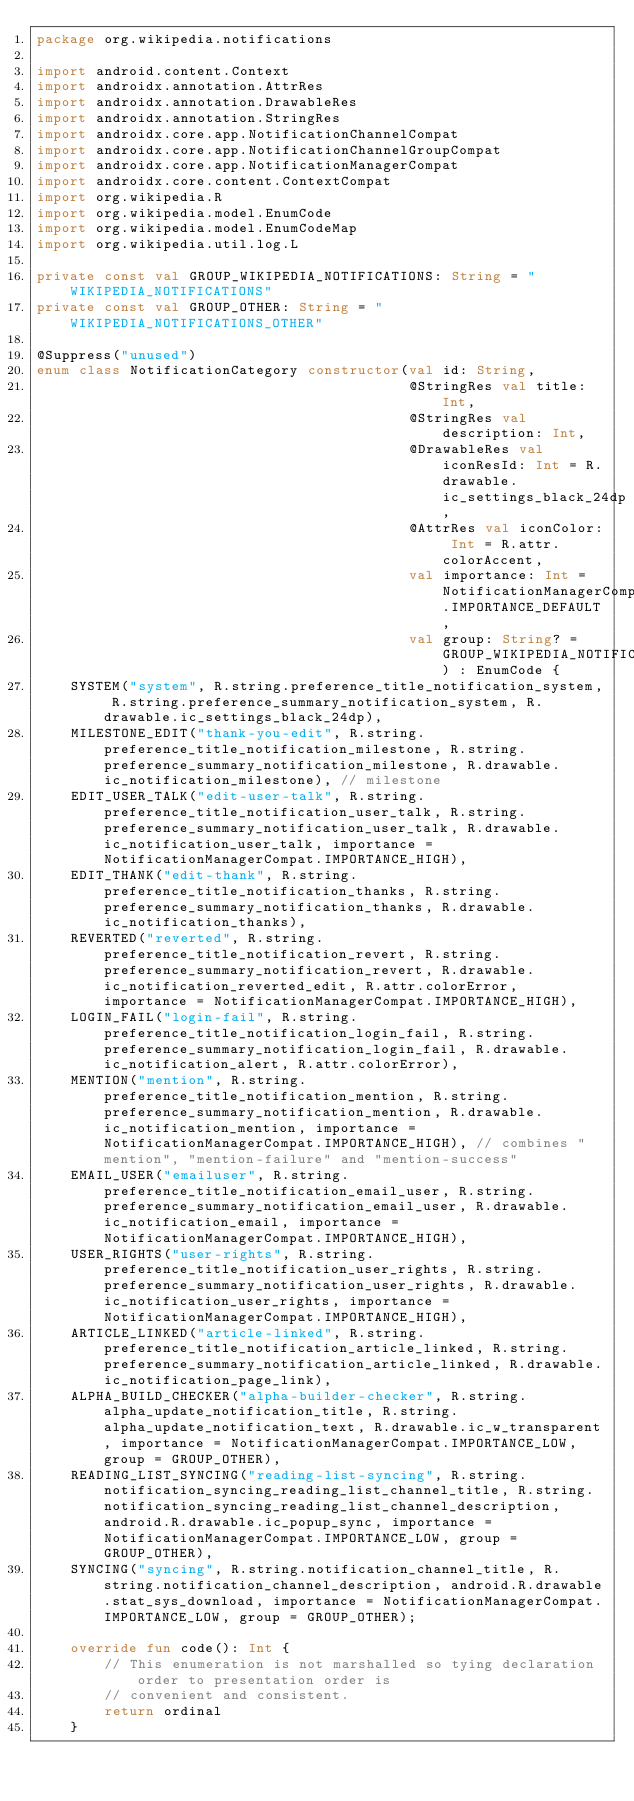<code> <loc_0><loc_0><loc_500><loc_500><_Kotlin_>package org.wikipedia.notifications

import android.content.Context
import androidx.annotation.AttrRes
import androidx.annotation.DrawableRes
import androidx.annotation.StringRes
import androidx.core.app.NotificationChannelCompat
import androidx.core.app.NotificationChannelGroupCompat
import androidx.core.app.NotificationManagerCompat
import androidx.core.content.ContextCompat
import org.wikipedia.R
import org.wikipedia.model.EnumCode
import org.wikipedia.model.EnumCodeMap
import org.wikipedia.util.log.L

private const val GROUP_WIKIPEDIA_NOTIFICATIONS: String = "WIKIPEDIA_NOTIFICATIONS"
private const val GROUP_OTHER: String = "WIKIPEDIA_NOTIFICATIONS_OTHER"

@Suppress("unused")
enum class NotificationCategory constructor(val id: String,
                                            @StringRes val title: Int,
                                            @StringRes val description: Int,
                                            @DrawableRes val iconResId: Int = R.drawable.ic_settings_black_24dp,
                                            @AttrRes val iconColor: Int = R.attr.colorAccent,
                                            val importance: Int = NotificationManagerCompat.IMPORTANCE_DEFAULT,
                                            val group: String? = GROUP_WIKIPEDIA_NOTIFICATIONS) : EnumCode {
    SYSTEM("system", R.string.preference_title_notification_system, R.string.preference_summary_notification_system, R.drawable.ic_settings_black_24dp),
    MILESTONE_EDIT("thank-you-edit", R.string.preference_title_notification_milestone, R.string.preference_summary_notification_milestone, R.drawable.ic_notification_milestone), // milestone
    EDIT_USER_TALK("edit-user-talk", R.string.preference_title_notification_user_talk, R.string.preference_summary_notification_user_talk, R.drawable.ic_notification_user_talk, importance = NotificationManagerCompat.IMPORTANCE_HIGH),
    EDIT_THANK("edit-thank", R.string.preference_title_notification_thanks, R.string.preference_summary_notification_thanks, R.drawable.ic_notification_thanks),
    REVERTED("reverted", R.string.preference_title_notification_revert, R.string.preference_summary_notification_revert, R.drawable.ic_notification_reverted_edit, R.attr.colorError, importance = NotificationManagerCompat.IMPORTANCE_HIGH),
    LOGIN_FAIL("login-fail", R.string.preference_title_notification_login_fail, R.string.preference_summary_notification_login_fail, R.drawable.ic_notification_alert, R.attr.colorError),
    MENTION("mention", R.string.preference_title_notification_mention, R.string.preference_summary_notification_mention, R.drawable.ic_notification_mention, importance = NotificationManagerCompat.IMPORTANCE_HIGH), // combines "mention", "mention-failure" and "mention-success"
    EMAIL_USER("emailuser", R.string.preference_title_notification_email_user, R.string.preference_summary_notification_email_user, R.drawable.ic_notification_email, importance = NotificationManagerCompat.IMPORTANCE_HIGH),
    USER_RIGHTS("user-rights", R.string.preference_title_notification_user_rights, R.string.preference_summary_notification_user_rights, R.drawable.ic_notification_user_rights, importance = NotificationManagerCompat.IMPORTANCE_HIGH),
    ARTICLE_LINKED("article-linked", R.string.preference_title_notification_article_linked, R.string.preference_summary_notification_article_linked, R.drawable.ic_notification_page_link),
    ALPHA_BUILD_CHECKER("alpha-builder-checker", R.string.alpha_update_notification_title, R.string.alpha_update_notification_text, R.drawable.ic_w_transparent, importance = NotificationManagerCompat.IMPORTANCE_LOW, group = GROUP_OTHER),
    READING_LIST_SYNCING("reading-list-syncing", R.string.notification_syncing_reading_list_channel_title, R.string.notification_syncing_reading_list_channel_description, android.R.drawable.ic_popup_sync, importance = NotificationManagerCompat.IMPORTANCE_LOW, group = GROUP_OTHER),
    SYNCING("syncing", R.string.notification_channel_title, R.string.notification_channel_description, android.R.drawable.stat_sys_download, importance = NotificationManagerCompat.IMPORTANCE_LOW, group = GROUP_OTHER);

    override fun code(): Int {
        // This enumeration is not marshalled so tying declaration order to presentation order is
        // convenient and consistent.
        return ordinal
    }
</code> 